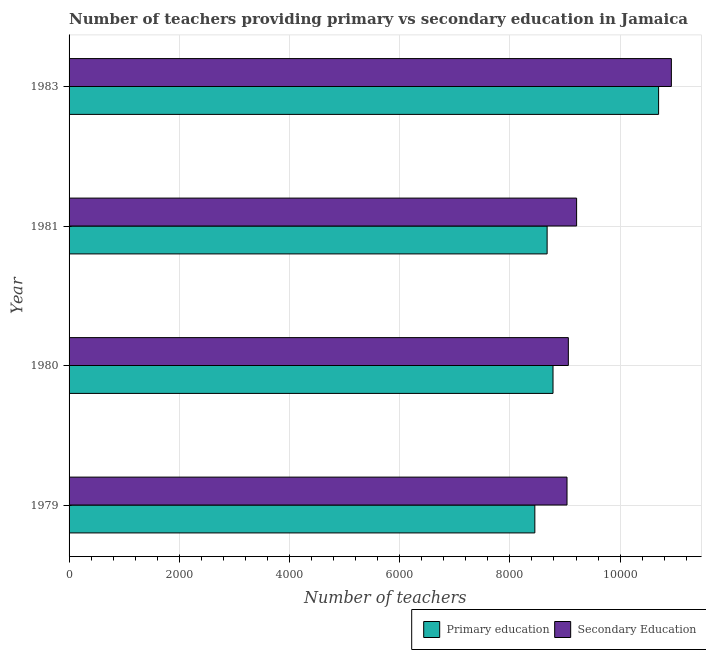How many different coloured bars are there?
Offer a terse response. 2. How many groups of bars are there?
Your response must be concise. 4. Are the number of bars per tick equal to the number of legend labels?
Keep it short and to the point. Yes. How many bars are there on the 4th tick from the top?
Keep it short and to the point. 2. How many bars are there on the 1st tick from the bottom?
Ensure brevity in your answer.  2. What is the label of the 3rd group of bars from the top?
Offer a terse response. 1980. In how many cases, is the number of bars for a given year not equal to the number of legend labels?
Make the answer very short. 0. What is the number of secondary teachers in 1981?
Offer a very short reply. 9211. Across all years, what is the maximum number of secondary teachers?
Your response must be concise. 1.09e+04. Across all years, what is the minimum number of secondary teachers?
Offer a very short reply. 9037. In which year was the number of primary teachers minimum?
Offer a very short reply. 1979. What is the total number of secondary teachers in the graph?
Provide a succinct answer. 3.82e+04. What is the difference between the number of primary teachers in 1979 and that in 1981?
Offer a terse response. -223. What is the difference between the number of secondary teachers in 1979 and the number of primary teachers in 1983?
Offer a very short reply. -1662. What is the average number of primary teachers per year?
Offer a very short reply. 9152.75. In the year 1979, what is the difference between the number of secondary teachers and number of primary teachers?
Provide a short and direct response. 584. Is the difference between the number of secondary teachers in 1980 and 1983 greater than the difference between the number of primary teachers in 1980 and 1983?
Give a very brief answer. Yes. What is the difference between the highest and the second highest number of primary teachers?
Give a very brief answer. 1916. What is the difference between the highest and the lowest number of secondary teachers?
Give a very brief answer. 1894. In how many years, is the number of primary teachers greater than the average number of primary teachers taken over all years?
Provide a succinct answer. 1. Is the sum of the number of primary teachers in 1981 and 1983 greater than the maximum number of secondary teachers across all years?
Ensure brevity in your answer.  Yes. What does the 1st bar from the top in 1983 represents?
Your answer should be compact. Secondary Education. What does the 1st bar from the bottom in 1979 represents?
Your answer should be compact. Primary education. How many bars are there?
Give a very brief answer. 8. Are all the bars in the graph horizontal?
Give a very brief answer. Yes. How many years are there in the graph?
Provide a succinct answer. 4. What is the difference between two consecutive major ticks on the X-axis?
Provide a short and direct response. 2000. Does the graph contain grids?
Ensure brevity in your answer.  Yes. How many legend labels are there?
Keep it short and to the point. 2. What is the title of the graph?
Ensure brevity in your answer.  Number of teachers providing primary vs secondary education in Jamaica. What is the label or title of the X-axis?
Keep it short and to the point. Number of teachers. What is the Number of teachers of Primary education in 1979?
Ensure brevity in your answer.  8453. What is the Number of teachers in Secondary Education in 1979?
Make the answer very short. 9037. What is the Number of teachers in Primary education in 1980?
Your response must be concise. 8783. What is the Number of teachers in Secondary Education in 1980?
Your answer should be very brief. 9061. What is the Number of teachers in Primary education in 1981?
Provide a succinct answer. 8676. What is the Number of teachers of Secondary Education in 1981?
Provide a short and direct response. 9211. What is the Number of teachers of Primary education in 1983?
Provide a succinct answer. 1.07e+04. What is the Number of teachers of Secondary Education in 1983?
Give a very brief answer. 1.09e+04. Across all years, what is the maximum Number of teachers of Primary education?
Offer a very short reply. 1.07e+04. Across all years, what is the maximum Number of teachers in Secondary Education?
Your answer should be compact. 1.09e+04. Across all years, what is the minimum Number of teachers in Primary education?
Your answer should be very brief. 8453. Across all years, what is the minimum Number of teachers in Secondary Education?
Give a very brief answer. 9037. What is the total Number of teachers in Primary education in the graph?
Provide a succinct answer. 3.66e+04. What is the total Number of teachers in Secondary Education in the graph?
Provide a succinct answer. 3.82e+04. What is the difference between the Number of teachers in Primary education in 1979 and that in 1980?
Make the answer very short. -330. What is the difference between the Number of teachers in Secondary Education in 1979 and that in 1980?
Offer a terse response. -24. What is the difference between the Number of teachers of Primary education in 1979 and that in 1981?
Your answer should be compact. -223. What is the difference between the Number of teachers of Secondary Education in 1979 and that in 1981?
Ensure brevity in your answer.  -174. What is the difference between the Number of teachers in Primary education in 1979 and that in 1983?
Offer a very short reply. -2246. What is the difference between the Number of teachers in Secondary Education in 1979 and that in 1983?
Keep it short and to the point. -1894. What is the difference between the Number of teachers in Primary education in 1980 and that in 1981?
Your answer should be compact. 107. What is the difference between the Number of teachers of Secondary Education in 1980 and that in 1981?
Offer a very short reply. -150. What is the difference between the Number of teachers of Primary education in 1980 and that in 1983?
Provide a succinct answer. -1916. What is the difference between the Number of teachers of Secondary Education in 1980 and that in 1983?
Your answer should be very brief. -1870. What is the difference between the Number of teachers of Primary education in 1981 and that in 1983?
Make the answer very short. -2023. What is the difference between the Number of teachers in Secondary Education in 1981 and that in 1983?
Offer a very short reply. -1720. What is the difference between the Number of teachers of Primary education in 1979 and the Number of teachers of Secondary Education in 1980?
Ensure brevity in your answer.  -608. What is the difference between the Number of teachers of Primary education in 1979 and the Number of teachers of Secondary Education in 1981?
Your answer should be very brief. -758. What is the difference between the Number of teachers of Primary education in 1979 and the Number of teachers of Secondary Education in 1983?
Provide a succinct answer. -2478. What is the difference between the Number of teachers in Primary education in 1980 and the Number of teachers in Secondary Education in 1981?
Give a very brief answer. -428. What is the difference between the Number of teachers of Primary education in 1980 and the Number of teachers of Secondary Education in 1983?
Your response must be concise. -2148. What is the difference between the Number of teachers in Primary education in 1981 and the Number of teachers in Secondary Education in 1983?
Offer a very short reply. -2255. What is the average Number of teachers in Primary education per year?
Your response must be concise. 9152.75. What is the average Number of teachers of Secondary Education per year?
Keep it short and to the point. 9560. In the year 1979, what is the difference between the Number of teachers in Primary education and Number of teachers in Secondary Education?
Give a very brief answer. -584. In the year 1980, what is the difference between the Number of teachers in Primary education and Number of teachers in Secondary Education?
Provide a succinct answer. -278. In the year 1981, what is the difference between the Number of teachers of Primary education and Number of teachers of Secondary Education?
Offer a terse response. -535. In the year 1983, what is the difference between the Number of teachers of Primary education and Number of teachers of Secondary Education?
Provide a succinct answer. -232. What is the ratio of the Number of teachers of Primary education in 1979 to that in 1980?
Your answer should be very brief. 0.96. What is the ratio of the Number of teachers of Secondary Education in 1979 to that in 1980?
Your answer should be very brief. 1. What is the ratio of the Number of teachers in Primary education in 1979 to that in 1981?
Your answer should be very brief. 0.97. What is the ratio of the Number of teachers in Secondary Education in 1979 to that in 1981?
Provide a short and direct response. 0.98. What is the ratio of the Number of teachers of Primary education in 1979 to that in 1983?
Make the answer very short. 0.79. What is the ratio of the Number of teachers in Secondary Education in 1979 to that in 1983?
Offer a very short reply. 0.83. What is the ratio of the Number of teachers of Primary education in 1980 to that in 1981?
Provide a succinct answer. 1.01. What is the ratio of the Number of teachers in Secondary Education in 1980 to that in 1981?
Make the answer very short. 0.98. What is the ratio of the Number of teachers in Primary education in 1980 to that in 1983?
Ensure brevity in your answer.  0.82. What is the ratio of the Number of teachers of Secondary Education in 1980 to that in 1983?
Ensure brevity in your answer.  0.83. What is the ratio of the Number of teachers in Primary education in 1981 to that in 1983?
Provide a short and direct response. 0.81. What is the ratio of the Number of teachers of Secondary Education in 1981 to that in 1983?
Your answer should be compact. 0.84. What is the difference between the highest and the second highest Number of teachers of Primary education?
Provide a succinct answer. 1916. What is the difference between the highest and the second highest Number of teachers in Secondary Education?
Your response must be concise. 1720. What is the difference between the highest and the lowest Number of teachers of Primary education?
Offer a terse response. 2246. What is the difference between the highest and the lowest Number of teachers of Secondary Education?
Make the answer very short. 1894. 